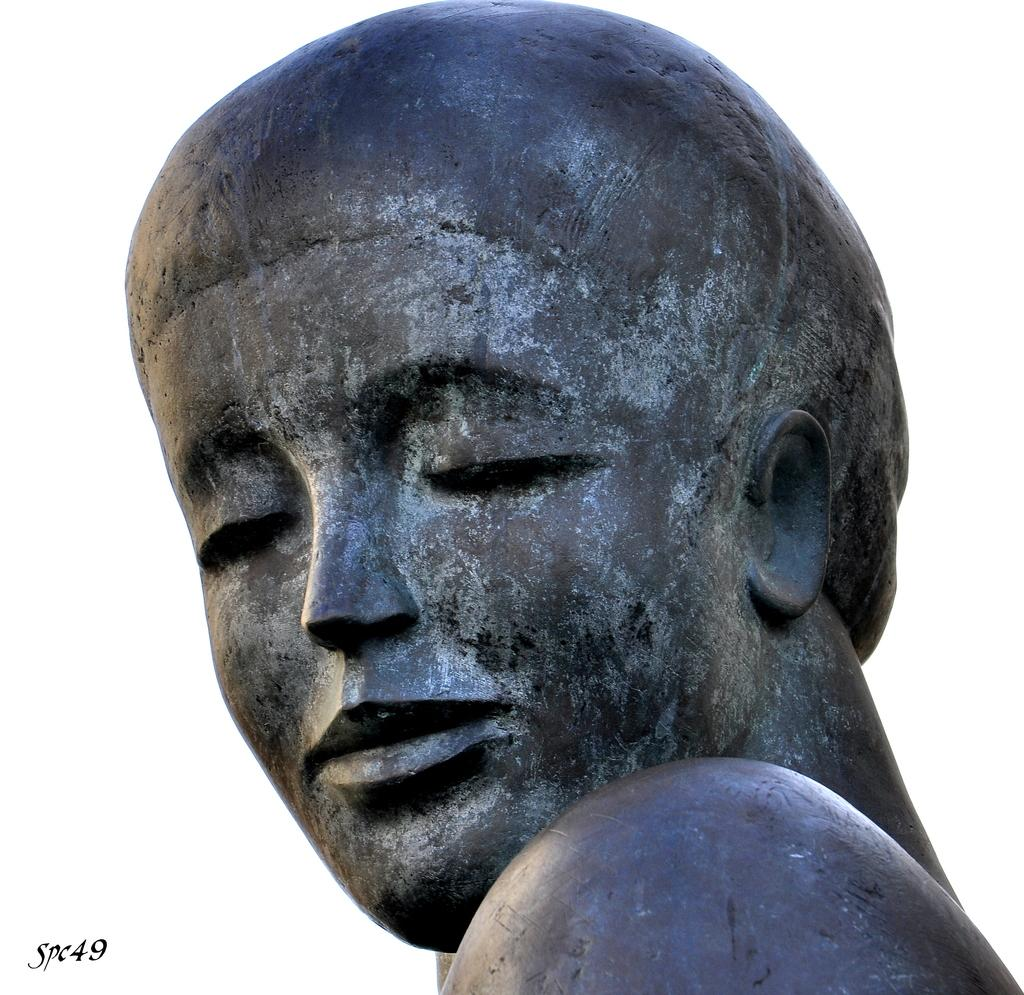What is the main subject of the image? There is a statue in the image. What color is the background of the image? The background of the image is white. Is there any additional information or branding present in the image? Yes, there is a watermark in the left bottom of the image. What type of art is the writer creating in the image? There is no writer or art creation visible in the image; it only features a statue and a white background. Is there a campground in the image? There is no campground or any indication of camping activities present in the image. 